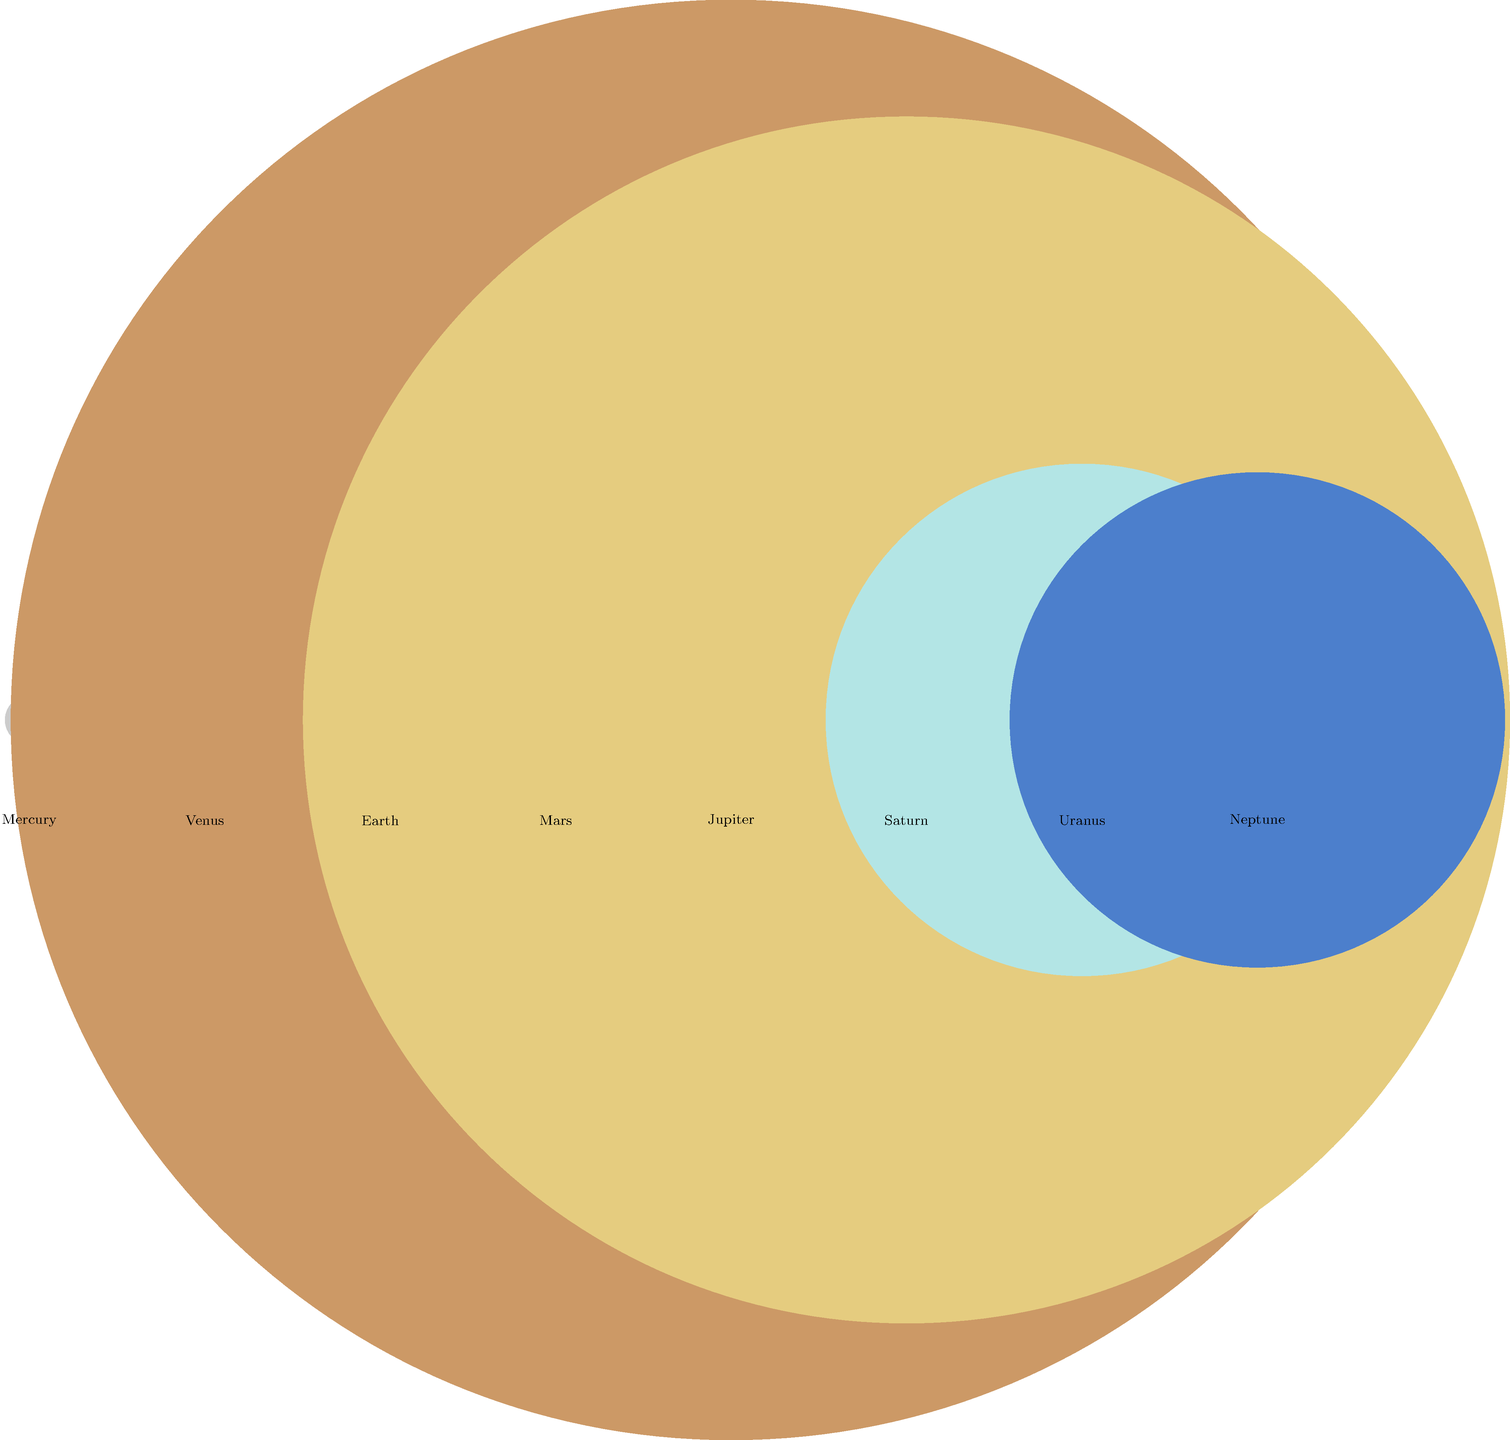As a frustrated UTEP Miners fan, you decide to distract yourself with some astronomy. Looking at this diagram of scaled planet sizes, which planet appears to be the closest in size to Uranus? Let's approach this step-by-step:

1. First, we need to identify Uranus in the diagram. Uranus is the second-largest blue circle, located second from the right.

2. Now, we need to compare Uranus' size to the other planets:
   - Mercury, Venus, Earth, and Mars are much smaller than Uranus.
   - Jupiter and Saturn are significantly larger than Uranus.
   - Neptune, the last planet on the right, appears very close in size to Uranus.

3. To confirm, let's look at the actual radii used in the diagram:
   - Uranus: 5.11 units
   - Neptune: 4.94 units

4. The difference between Uranus and Neptune is only 0.17 units, which is much smaller than the difference between Uranus and any other planet.

5. This small difference explains why Neptune appears to be the closest in size to Uranus in the diagram.

Even though you might be feeling down about the UTEP Miners, at least you can take solace in the fact that the universe operates on consistent principles, unlike the unpredictable nature of sports!
Answer: Neptune 